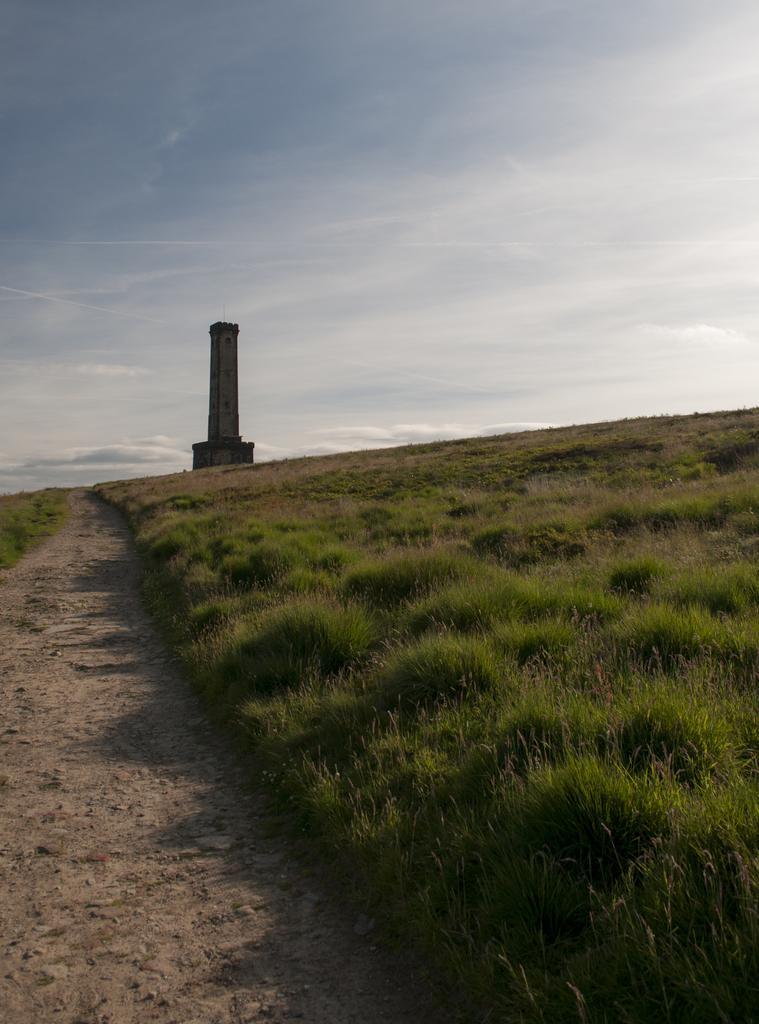Can you describe this image briefly? In this image there is grass, and sand at the bottom there is walkway. And in the background there is one tower, at the top there is sky. 